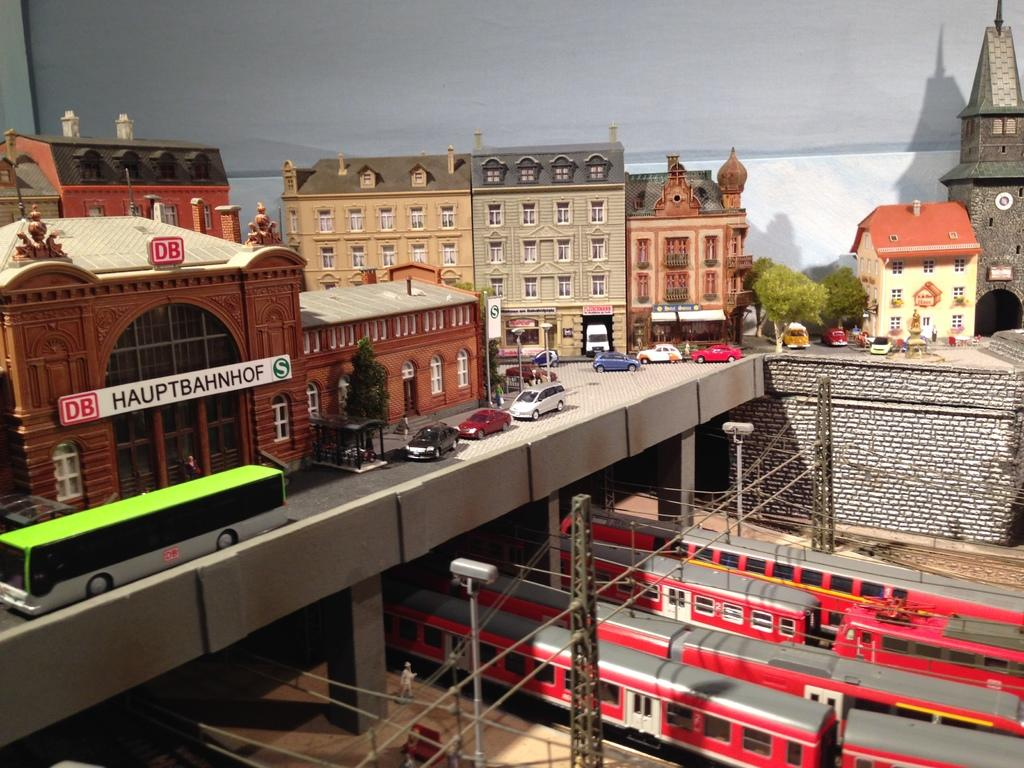What type of vehicles are located at the bottom side of the image? There are trains at the bottom side of the image. What structures can be seen at the top side of the image? There are buildings at the top side of the image. What other type of vehicles are present at the top side of the image? There are cars at the top side of the image. Can you describe the rainstorm happening in the image? There is no rainstorm present in the image. How many brothers are visible in the image? There are no people, let alone brothers, present in the image. 